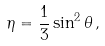<formula> <loc_0><loc_0><loc_500><loc_500>\eta = \frac { 1 } { 3 } \sin ^ { 2 } \theta \, ,</formula> 